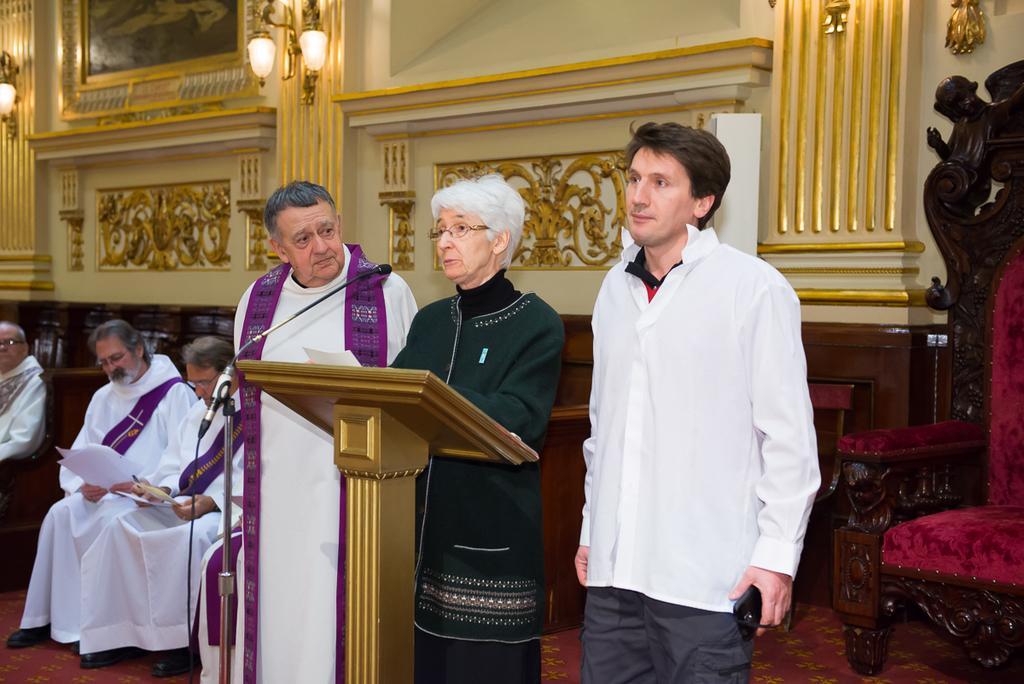In one or two sentences, can you explain what this image depicts? In this picture we can see three people and in front of them we can see a mic, paper, podium and at the back of them we can see some people sitting on chairs, frame, lights and some objects. 